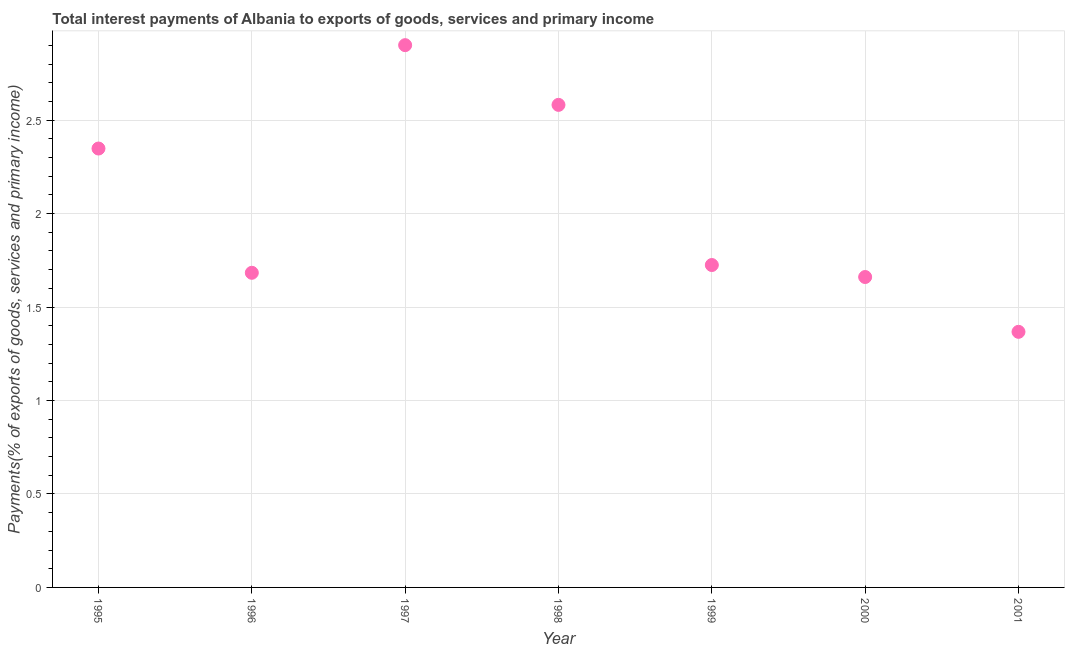What is the total interest payments on external debt in 1997?
Provide a succinct answer. 2.9. Across all years, what is the maximum total interest payments on external debt?
Ensure brevity in your answer.  2.9. Across all years, what is the minimum total interest payments on external debt?
Your answer should be very brief. 1.37. In which year was the total interest payments on external debt minimum?
Offer a terse response. 2001. What is the sum of the total interest payments on external debt?
Your response must be concise. 14.27. What is the difference between the total interest payments on external debt in 1998 and 1999?
Your answer should be very brief. 0.86. What is the average total interest payments on external debt per year?
Your answer should be very brief. 2.04. What is the median total interest payments on external debt?
Provide a short and direct response. 1.72. In how many years, is the total interest payments on external debt greater than 1.8 %?
Offer a very short reply. 3. What is the ratio of the total interest payments on external debt in 1996 to that in 1997?
Provide a short and direct response. 0.58. What is the difference between the highest and the second highest total interest payments on external debt?
Offer a terse response. 0.32. What is the difference between the highest and the lowest total interest payments on external debt?
Keep it short and to the point. 1.53. In how many years, is the total interest payments on external debt greater than the average total interest payments on external debt taken over all years?
Keep it short and to the point. 3. Does the total interest payments on external debt monotonically increase over the years?
Your answer should be compact. No. How many dotlines are there?
Ensure brevity in your answer.  1. What is the difference between two consecutive major ticks on the Y-axis?
Your answer should be very brief. 0.5. Are the values on the major ticks of Y-axis written in scientific E-notation?
Offer a terse response. No. Does the graph contain any zero values?
Make the answer very short. No. Does the graph contain grids?
Ensure brevity in your answer.  Yes. What is the title of the graph?
Make the answer very short. Total interest payments of Albania to exports of goods, services and primary income. What is the label or title of the Y-axis?
Offer a terse response. Payments(% of exports of goods, services and primary income). What is the Payments(% of exports of goods, services and primary income) in 1995?
Provide a short and direct response. 2.35. What is the Payments(% of exports of goods, services and primary income) in 1996?
Give a very brief answer. 1.68. What is the Payments(% of exports of goods, services and primary income) in 1997?
Provide a succinct answer. 2.9. What is the Payments(% of exports of goods, services and primary income) in 1998?
Offer a terse response. 2.58. What is the Payments(% of exports of goods, services and primary income) in 1999?
Offer a very short reply. 1.72. What is the Payments(% of exports of goods, services and primary income) in 2000?
Your answer should be very brief. 1.66. What is the Payments(% of exports of goods, services and primary income) in 2001?
Your response must be concise. 1.37. What is the difference between the Payments(% of exports of goods, services and primary income) in 1995 and 1996?
Your answer should be compact. 0.66. What is the difference between the Payments(% of exports of goods, services and primary income) in 1995 and 1997?
Make the answer very short. -0.55. What is the difference between the Payments(% of exports of goods, services and primary income) in 1995 and 1998?
Give a very brief answer. -0.23. What is the difference between the Payments(% of exports of goods, services and primary income) in 1995 and 1999?
Keep it short and to the point. 0.62. What is the difference between the Payments(% of exports of goods, services and primary income) in 1995 and 2000?
Keep it short and to the point. 0.69. What is the difference between the Payments(% of exports of goods, services and primary income) in 1995 and 2001?
Keep it short and to the point. 0.98. What is the difference between the Payments(% of exports of goods, services and primary income) in 1996 and 1997?
Keep it short and to the point. -1.22. What is the difference between the Payments(% of exports of goods, services and primary income) in 1996 and 1998?
Offer a very short reply. -0.9. What is the difference between the Payments(% of exports of goods, services and primary income) in 1996 and 1999?
Provide a short and direct response. -0.04. What is the difference between the Payments(% of exports of goods, services and primary income) in 1996 and 2000?
Offer a terse response. 0.02. What is the difference between the Payments(% of exports of goods, services and primary income) in 1996 and 2001?
Ensure brevity in your answer.  0.32. What is the difference between the Payments(% of exports of goods, services and primary income) in 1997 and 1998?
Provide a short and direct response. 0.32. What is the difference between the Payments(% of exports of goods, services and primary income) in 1997 and 1999?
Your answer should be very brief. 1.18. What is the difference between the Payments(% of exports of goods, services and primary income) in 1997 and 2000?
Offer a very short reply. 1.24. What is the difference between the Payments(% of exports of goods, services and primary income) in 1997 and 2001?
Provide a succinct answer. 1.53. What is the difference between the Payments(% of exports of goods, services and primary income) in 1998 and 1999?
Ensure brevity in your answer.  0.86. What is the difference between the Payments(% of exports of goods, services and primary income) in 1998 and 2000?
Your answer should be compact. 0.92. What is the difference between the Payments(% of exports of goods, services and primary income) in 1998 and 2001?
Make the answer very short. 1.21. What is the difference between the Payments(% of exports of goods, services and primary income) in 1999 and 2000?
Your response must be concise. 0.06. What is the difference between the Payments(% of exports of goods, services and primary income) in 1999 and 2001?
Offer a terse response. 0.36. What is the difference between the Payments(% of exports of goods, services and primary income) in 2000 and 2001?
Your response must be concise. 0.29. What is the ratio of the Payments(% of exports of goods, services and primary income) in 1995 to that in 1996?
Your response must be concise. 1.4. What is the ratio of the Payments(% of exports of goods, services and primary income) in 1995 to that in 1997?
Your answer should be compact. 0.81. What is the ratio of the Payments(% of exports of goods, services and primary income) in 1995 to that in 1998?
Your answer should be compact. 0.91. What is the ratio of the Payments(% of exports of goods, services and primary income) in 1995 to that in 1999?
Your response must be concise. 1.36. What is the ratio of the Payments(% of exports of goods, services and primary income) in 1995 to that in 2000?
Offer a terse response. 1.41. What is the ratio of the Payments(% of exports of goods, services and primary income) in 1995 to that in 2001?
Give a very brief answer. 1.72. What is the ratio of the Payments(% of exports of goods, services and primary income) in 1996 to that in 1997?
Provide a succinct answer. 0.58. What is the ratio of the Payments(% of exports of goods, services and primary income) in 1996 to that in 1998?
Your answer should be very brief. 0.65. What is the ratio of the Payments(% of exports of goods, services and primary income) in 1996 to that in 2000?
Your response must be concise. 1.01. What is the ratio of the Payments(% of exports of goods, services and primary income) in 1996 to that in 2001?
Keep it short and to the point. 1.23. What is the ratio of the Payments(% of exports of goods, services and primary income) in 1997 to that in 1998?
Your answer should be very brief. 1.12. What is the ratio of the Payments(% of exports of goods, services and primary income) in 1997 to that in 1999?
Keep it short and to the point. 1.68. What is the ratio of the Payments(% of exports of goods, services and primary income) in 1997 to that in 2000?
Provide a succinct answer. 1.75. What is the ratio of the Payments(% of exports of goods, services and primary income) in 1997 to that in 2001?
Provide a short and direct response. 2.12. What is the ratio of the Payments(% of exports of goods, services and primary income) in 1998 to that in 1999?
Offer a terse response. 1.5. What is the ratio of the Payments(% of exports of goods, services and primary income) in 1998 to that in 2000?
Provide a short and direct response. 1.55. What is the ratio of the Payments(% of exports of goods, services and primary income) in 1998 to that in 2001?
Ensure brevity in your answer.  1.89. What is the ratio of the Payments(% of exports of goods, services and primary income) in 1999 to that in 2000?
Your answer should be very brief. 1.04. What is the ratio of the Payments(% of exports of goods, services and primary income) in 1999 to that in 2001?
Your response must be concise. 1.26. What is the ratio of the Payments(% of exports of goods, services and primary income) in 2000 to that in 2001?
Make the answer very short. 1.21. 